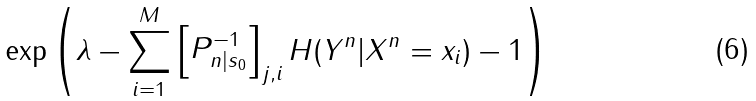<formula> <loc_0><loc_0><loc_500><loc_500>\exp \left ( \lambda - \sum _ { i = 1 } ^ { M } \begin{bmatrix} P _ { n | s _ { 0 } } ^ { - 1 } \end{bmatrix} _ { j , i } H ( Y ^ { n } | X ^ { n } = x _ { i } ) - 1 \right )</formula> 